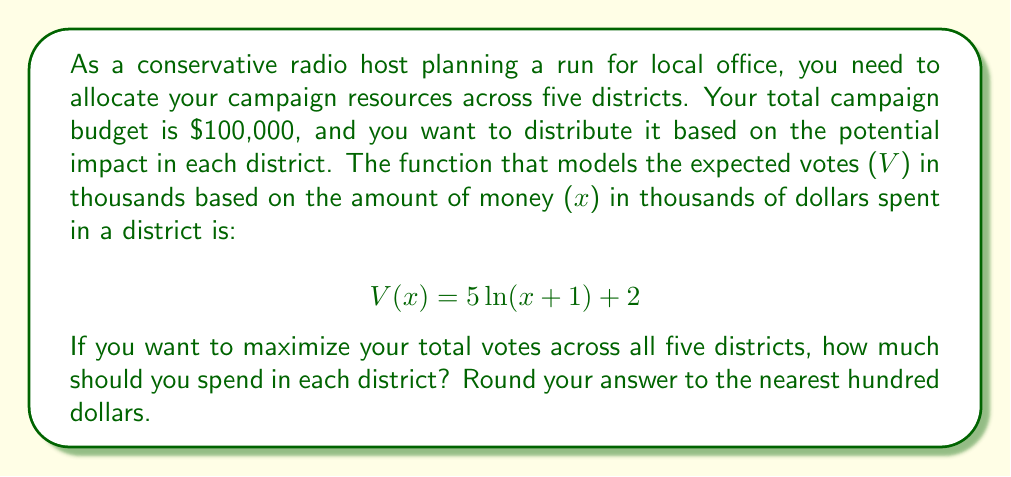Can you solve this math problem? To solve this problem, we need to use the method of Lagrange multipliers, as we're maximizing a function subject to a constraint.

1) First, let's set up our function to maximize. We want to maximize the total votes across all five districts:

   $$f(x_1, x_2, x_3, x_4, x_5) = V(x_1) + V(x_2) + V(x_3) + V(x_4) + V(x_5)$$

2) Our constraint is that the total spending must equal $100,000:

   $$g(x_1, x_2, x_3, x_4, x_5) = x_1 + x_2 + x_3 + x_4 + x_5 = 100$$

3) Now, we set up the Lagrangian:

   $$L = f(x_1, x_2, x_3, x_4, x_5) - \lambda g(x_1, x_2, x_3, x_4, x_5)$$

4) We take partial derivatives with respect to each variable and set them equal to zero:

   $$\frac{\partial L}{\partial x_i} = \frac{5}{x_i+1} - \lambda = 0$$
   $$\frac{\partial L}{\partial \lambda} = x_1 + x_2 + x_3 + x_4 + x_5 - 100 = 0$$

5) From the first equation, we can see that all $x_i$ must be equal (let's call this value $x$), because $\lambda$ is constant:

   $$x_i = \frac{5}{\lambda} - 1$$

6) Substituting this into our constraint equation:

   $$5(\frac{5}{\lambda} - 1) = 100$$

7) Solving for $\lambda$:

   $$\frac{25}{\lambda} - 5 = 100$$
   $$\frac{25}{\lambda} = 105$$
   $$\lambda = \frac{25}{105} = \frac{5}{21}$$

8) Now we can solve for $x$:

   $$x = \frac{5}{\lambda} - 1 = \frac{5}{\frac{5}{21}} - 1 = 21 - 1 = 20$$

Therefore, the optimal distribution is to spend $20,000 in each of the five districts.
Answer: $20,000 in each district 